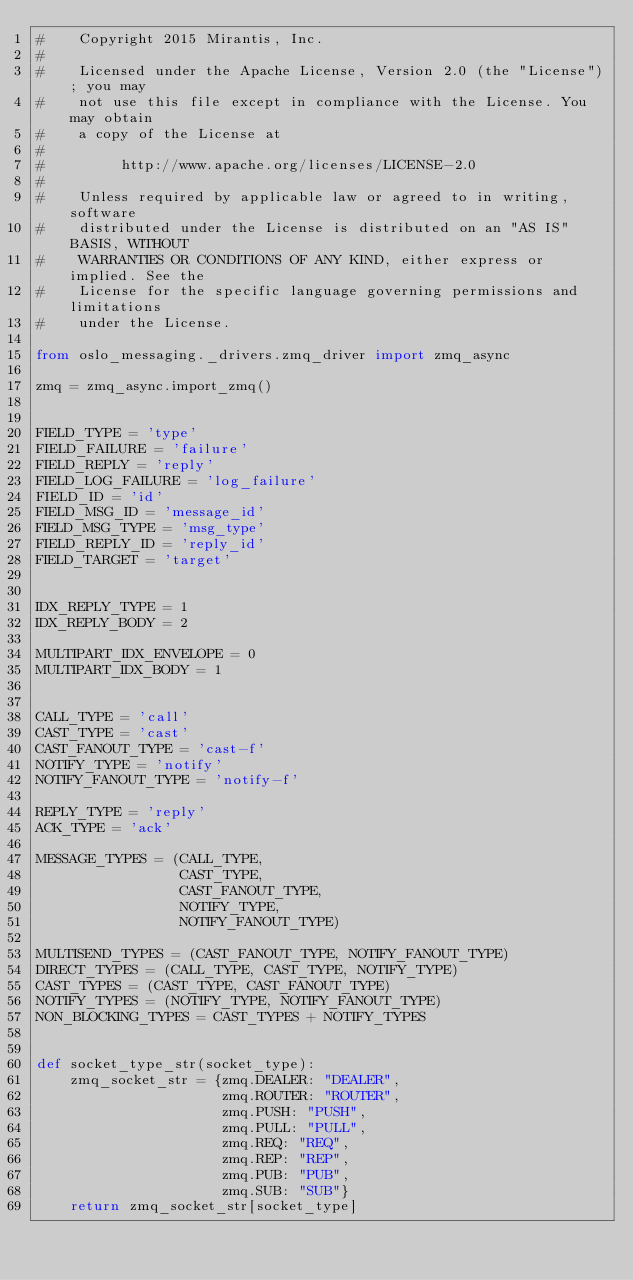<code> <loc_0><loc_0><loc_500><loc_500><_Python_>#    Copyright 2015 Mirantis, Inc.
#
#    Licensed under the Apache License, Version 2.0 (the "License"); you may
#    not use this file except in compliance with the License. You may obtain
#    a copy of the License at
#
#         http://www.apache.org/licenses/LICENSE-2.0
#
#    Unless required by applicable law or agreed to in writing, software
#    distributed under the License is distributed on an "AS IS" BASIS, WITHOUT
#    WARRANTIES OR CONDITIONS OF ANY KIND, either express or implied. See the
#    License for the specific language governing permissions and limitations
#    under the License.

from oslo_messaging._drivers.zmq_driver import zmq_async

zmq = zmq_async.import_zmq()


FIELD_TYPE = 'type'
FIELD_FAILURE = 'failure'
FIELD_REPLY = 'reply'
FIELD_LOG_FAILURE = 'log_failure'
FIELD_ID = 'id'
FIELD_MSG_ID = 'message_id'
FIELD_MSG_TYPE = 'msg_type'
FIELD_REPLY_ID = 'reply_id'
FIELD_TARGET = 'target'


IDX_REPLY_TYPE = 1
IDX_REPLY_BODY = 2

MULTIPART_IDX_ENVELOPE = 0
MULTIPART_IDX_BODY = 1


CALL_TYPE = 'call'
CAST_TYPE = 'cast'
CAST_FANOUT_TYPE = 'cast-f'
NOTIFY_TYPE = 'notify'
NOTIFY_FANOUT_TYPE = 'notify-f'

REPLY_TYPE = 'reply'
ACK_TYPE = 'ack'

MESSAGE_TYPES = (CALL_TYPE,
                 CAST_TYPE,
                 CAST_FANOUT_TYPE,
                 NOTIFY_TYPE,
                 NOTIFY_FANOUT_TYPE)

MULTISEND_TYPES = (CAST_FANOUT_TYPE, NOTIFY_FANOUT_TYPE)
DIRECT_TYPES = (CALL_TYPE, CAST_TYPE, NOTIFY_TYPE)
CAST_TYPES = (CAST_TYPE, CAST_FANOUT_TYPE)
NOTIFY_TYPES = (NOTIFY_TYPE, NOTIFY_FANOUT_TYPE)
NON_BLOCKING_TYPES = CAST_TYPES + NOTIFY_TYPES


def socket_type_str(socket_type):
    zmq_socket_str = {zmq.DEALER: "DEALER",
                      zmq.ROUTER: "ROUTER",
                      zmq.PUSH: "PUSH",
                      zmq.PULL: "PULL",
                      zmq.REQ: "REQ",
                      zmq.REP: "REP",
                      zmq.PUB: "PUB",
                      zmq.SUB: "SUB"}
    return zmq_socket_str[socket_type]
</code> 